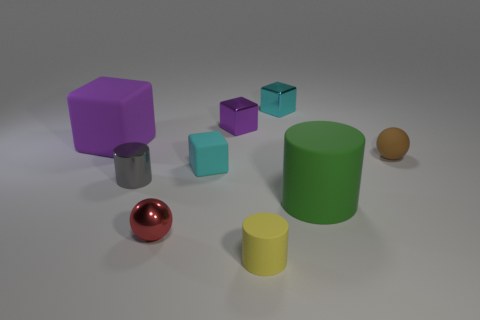What is the material of the object that is the same color as the large matte cube?
Your answer should be compact. Metal. How many purple metallic things are the same shape as the purple rubber object?
Your response must be concise. 1. Is the tiny brown ball made of the same material as the small cylinder behind the tiny matte cylinder?
Give a very brief answer. No. What number of green cubes are there?
Ensure brevity in your answer.  0. There is a purple matte cube behind the big green thing; how big is it?
Keep it short and to the point. Large. How many shiny blocks are the same size as the gray thing?
Provide a succinct answer. 2. The thing that is both to the left of the small red shiny thing and in front of the small brown sphere is made of what material?
Ensure brevity in your answer.  Metal. There is a red ball that is the same size as the gray object; what is it made of?
Your answer should be compact. Metal. There is a cylinder in front of the small sphere in front of the tiny cyan object on the left side of the small yellow cylinder; what size is it?
Give a very brief answer. Small. What size is the purple thing that is the same material as the large cylinder?
Your response must be concise. Large. 